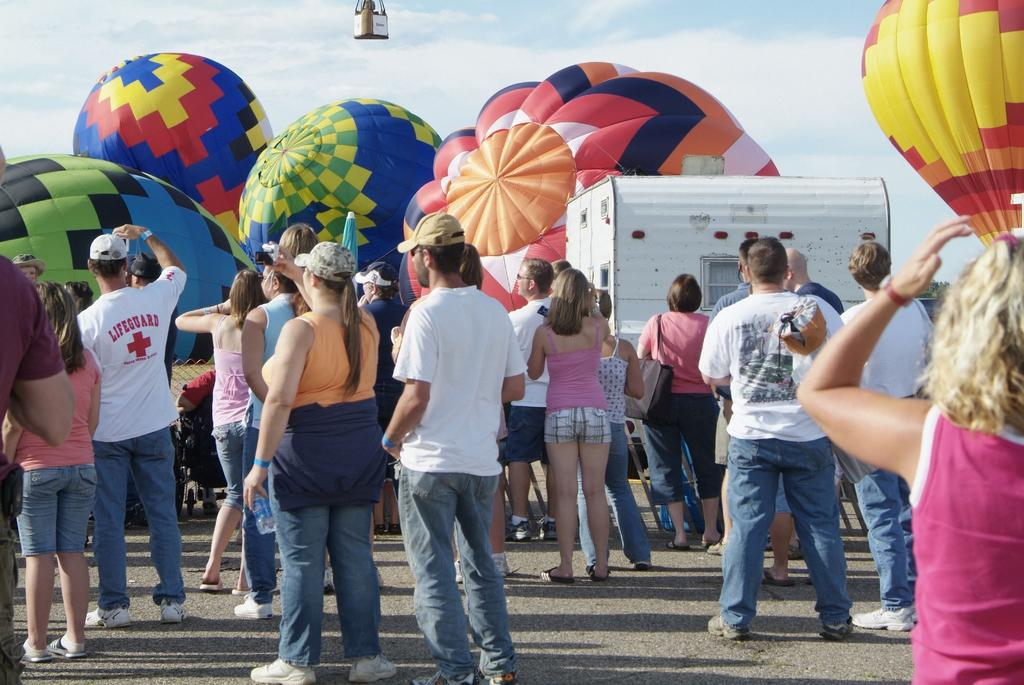What is happening in the image? There are people standing in the image. What are the people using in the image? There are parachutes visible in the image. What can be seen in the background of the image? There is sky in the background of the image. What type of birthday celebration is taking place in the image? There is no indication of a birthday celebration in the image; it features people with parachutes and a sky background. What stage of development is the earth in the image? The image does not depict the earth; it shows people with parachutes and a sky background. 